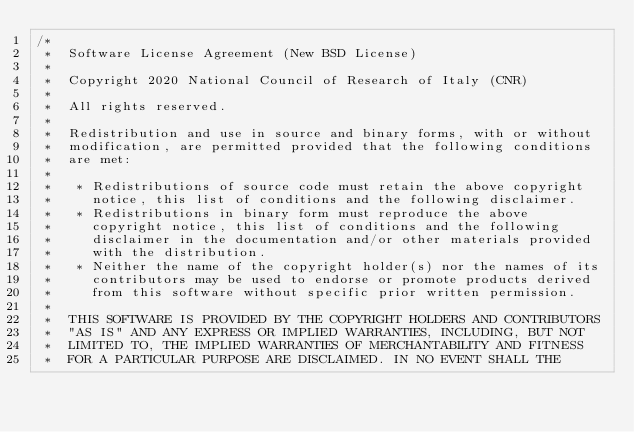<code> <loc_0><loc_0><loc_500><loc_500><_C++_>/*
 *  Software License Agreement (New BSD License)
 *
 *  Copyright 2020 National Council of Research of Italy (CNR)
 *
 *  All rights reserved.
 *
 *  Redistribution and use in source and binary forms, with or without
 *  modification, are permitted provided that the following conditions
 *  are met:
 *
 *   * Redistributions of source code must retain the above copyright
 *     notice, this list of conditions and the following disclaimer.
 *   * Redistributions in binary form must reproduce the above
 *     copyright notice, this list of conditions and the following
 *     disclaimer in the documentation and/or other materials provided
 *     with the distribution.
 *   * Neither the name of the copyright holder(s) nor the names of its
 *     contributors may be used to endorse or promote products derived
 *     from this software without specific prior written permission.
 *
 *  THIS SOFTWARE IS PROVIDED BY THE COPYRIGHT HOLDERS AND CONTRIBUTORS
 *  "AS IS" AND ANY EXPRESS OR IMPLIED WARRANTIES, INCLUDING, BUT NOT
 *  LIMITED TO, THE IMPLIED WARRANTIES OF MERCHANTABILITY AND FITNESS
 *  FOR A PARTICULAR PURPOSE ARE DISCLAIMED. IN NO EVENT SHALL THE</code> 